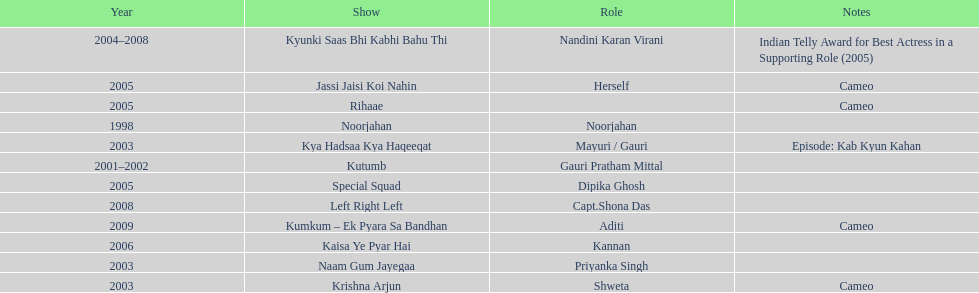Help me parse the entirety of this table. {'header': ['Year', 'Show', 'Role', 'Notes'], 'rows': [['2004–2008', 'Kyunki Saas Bhi Kabhi Bahu Thi', 'Nandini Karan Virani', 'Indian Telly Award for Best Actress in a Supporting Role (2005)'], ['2005', 'Jassi Jaisi Koi Nahin', 'Herself', 'Cameo'], ['2005', 'Rihaae', '', 'Cameo'], ['1998', 'Noorjahan', 'Noorjahan', ''], ['2003', 'Kya Hadsaa Kya Haqeeqat', 'Mayuri / Gauri', 'Episode: Kab Kyun Kahan'], ['2001–2002', 'Kutumb', 'Gauri Pratham Mittal', ''], ['2005', 'Special Squad', 'Dipika Ghosh', ''], ['2008', 'Left Right Left', 'Capt.Shona Das', ''], ['2009', 'Kumkum – Ek Pyara Sa Bandhan', 'Aditi', 'Cameo'], ['2006', 'Kaisa Ye Pyar Hai', 'Kannan', ''], ['2003', 'Naam Gum Jayegaa', 'Priyanka Singh', ''], ['2003', 'Krishna Arjun', 'Shweta', 'Cameo']]} What was the first tv series that gauri tejwani appeared in? Noorjahan. 